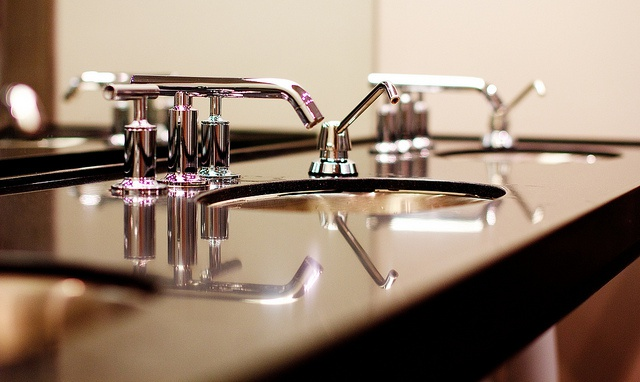Describe the objects in this image and their specific colors. I can see sink in maroon, black, lightgray, and tan tones and sink in maroon, white, and tan tones in this image. 